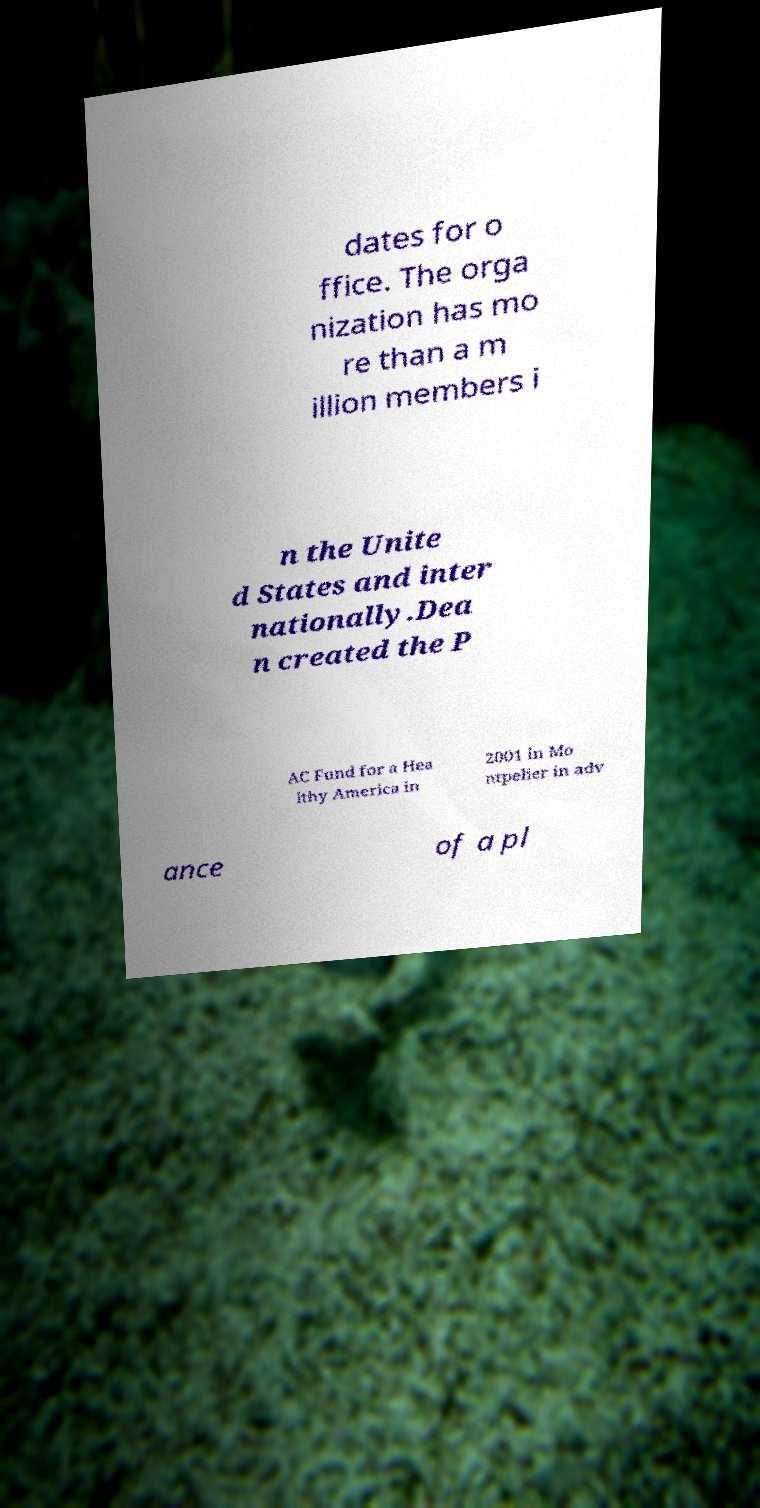Please identify and transcribe the text found in this image. dates for o ffice. The orga nization has mo re than a m illion members i n the Unite d States and inter nationally.Dea n created the P AC Fund for a Hea lthy America in 2001 in Mo ntpelier in adv ance of a pl 